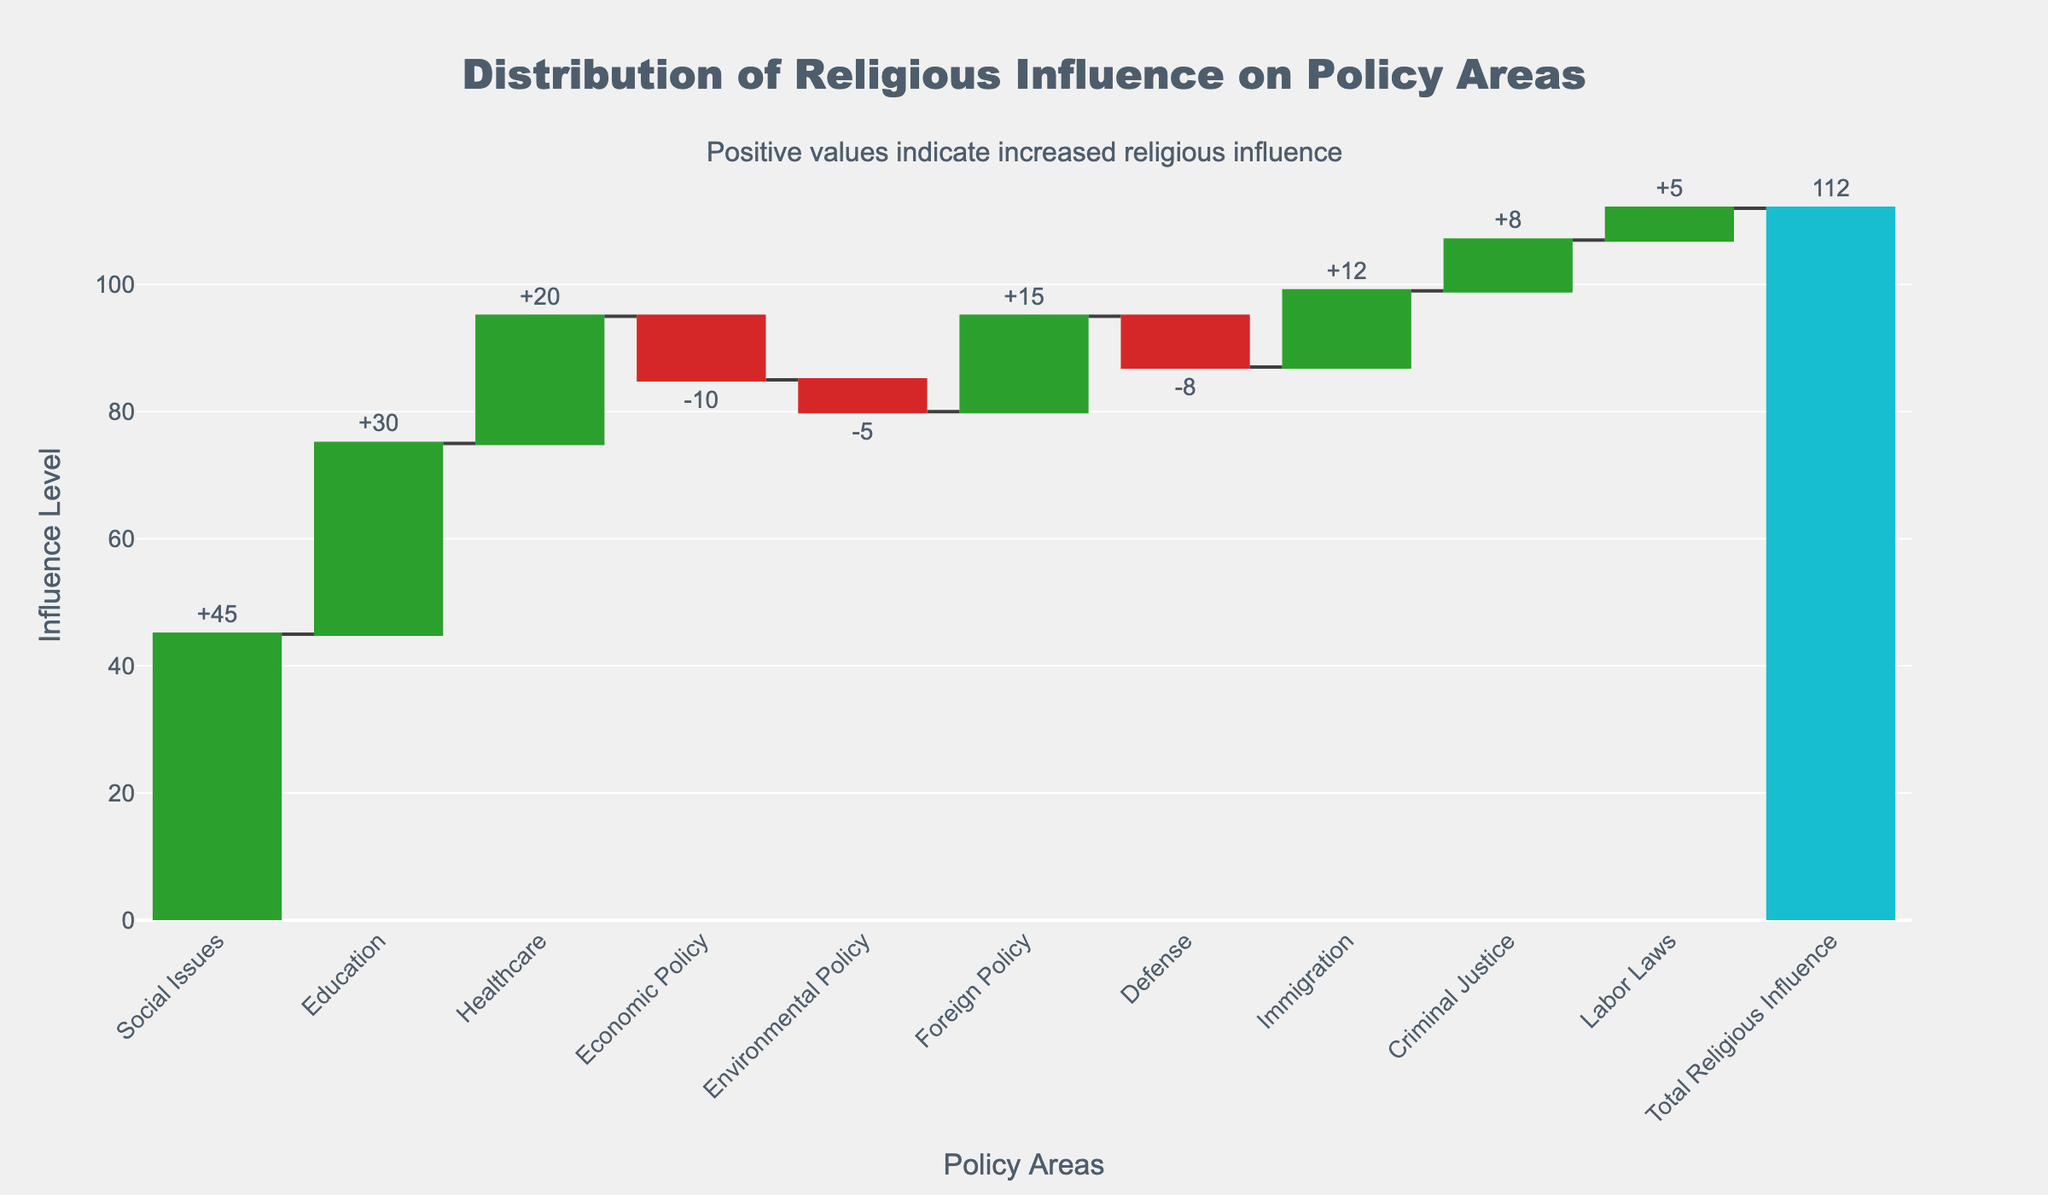What is the title of the chart? The title is usually at the top of the chart and provides a summary of what the chart depicts.
Answer: Distribution of Religious Influence on Policy Areas Which policy area has the highest level of religious influence? By examining the chart, the policy area with the tallest green bar is the one with the highest level of religious influence.
Answer: Social Issues How much influence does religion have on education policy? Look at the bar labeled "Education" and check the value indicated.
Answer: 30 Which policy areas show a decrease in religious influence? Negative bars, usually colored differently (like red), indicate a decrease in influence. Look at these bars and identify the policy areas they represent.
Answer: Economic Policy, Environmental Policy, Defense What is the total religious influence across all policy areas? The total influence is often provided at the end of a waterfall chart, indicated by a unique color bar and displayed value.
Answer: 112 By how much does religious influence on social issues exceed the influence on healthcare? Subtract the influence on healthcare from the influence on social issues (45 - 20).
Answer: 25 Which policy area shows the least religious influence and what is the value? Find the smallest positive or least negative value among the policy areas.
Answer: Labor Laws, 5 How does religious influence on foreign policy compare to that on immigration? Look at the values and compare them; the comparison will show whether one is greater or lesser relative to the other.
Answer: Foreign Policy is greater than Immigration What are the combined total influences on labor laws and criminal justice? Add the values for labor laws and criminal justice (5 + 8).
Answer: 13 How many policy areas are shown to have a positive influence from religion? Count the number of green bars that indicate a positive influence on policy areas.
Answer: 7 